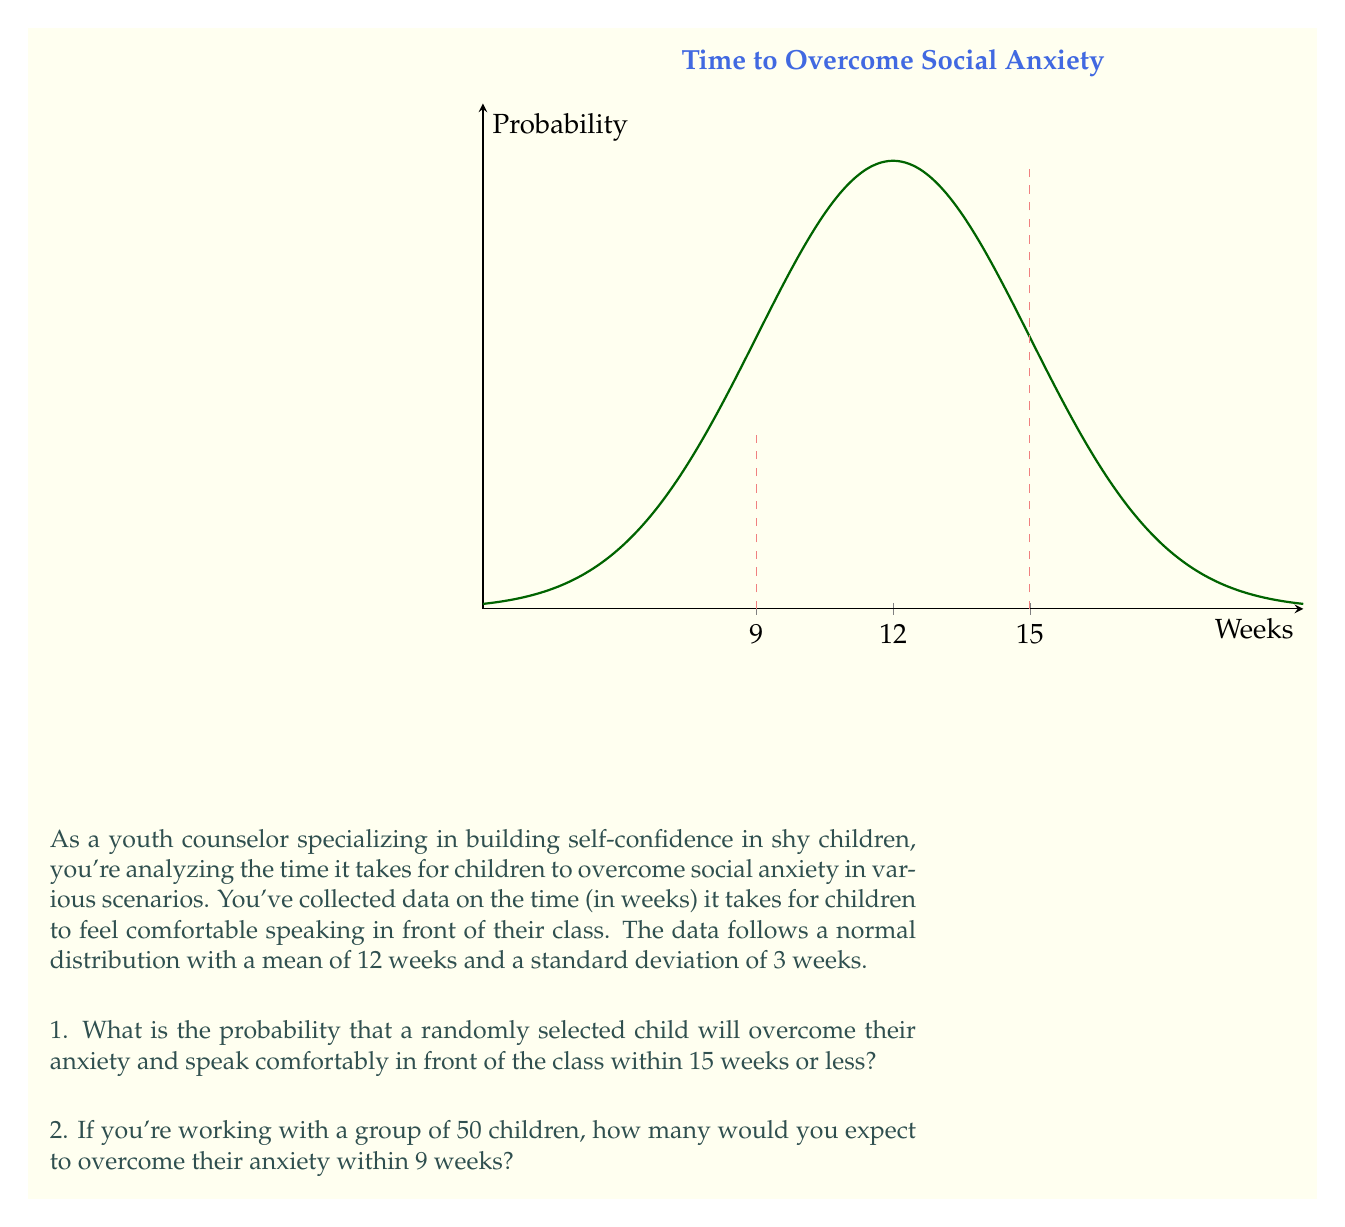Can you answer this question? Let's approach this problem step-by-step:

1. For the first part of the question:
   - We're dealing with a normal distribution with $\mu = 12$ and $\sigma = 3$.
   - We want to find $P(X \leq 15)$, where $X$ is the time in weeks.
   - To do this, we need to calculate the z-score:
     $$z = \frac{X - \mu}{\sigma} = \frac{15 - 12}{3} = 1$$
   - Now we can use a standard normal table or calculator to find $P(Z \leq 1)$.
   - This probability is approximately 0.8413 or 84.13%.

2. For the second part:
   - We need to find $P(X \leq 9)$ and then multiply by the number of children.
   - The z-score for 9 weeks is:
     $$z = \frac{9 - 12}{3} = -1$$
   - $P(Z \leq -1)$ is approximately 0.1587 or 15.87%.
   - In a group of 50 children, we would expect:
     $$50 \times 0.1587 \approx 7.935$$
   - Since we can't have a fraction of a child, we round to the nearest whole number: 8.

Therefore, we would expect about 8 children out of 50 to overcome their anxiety within 9 weeks.
Answer: 1. 84.13%
2. 8 children 